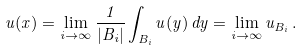<formula> <loc_0><loc_0><loc_500><loc_500>u ( x ) = \lim _ { i \to \infty } \frac { 1 } { | B _ { i } | } \int _ { B _ { i } } u ( y ) \, d y = \lim _ { i \to \infty } u _ { B _ { i } } \, .</formula> 